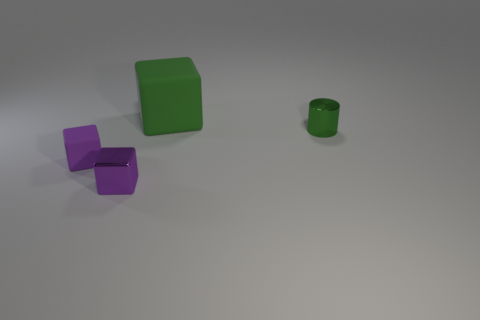How many objects are there in total in this image? There are three objects in this image: a green matte cube, two purple matte blocks connected together, and a small green cylindrical container.  What materials do the objects look like they are made from? The solidity and lack of shine suggest that the green cube and the purple blocks are likely made of a matte plastic or similarly opaque material. The green cylindrical container also has a matte finish, implying it might be made from a similar plastic material. 